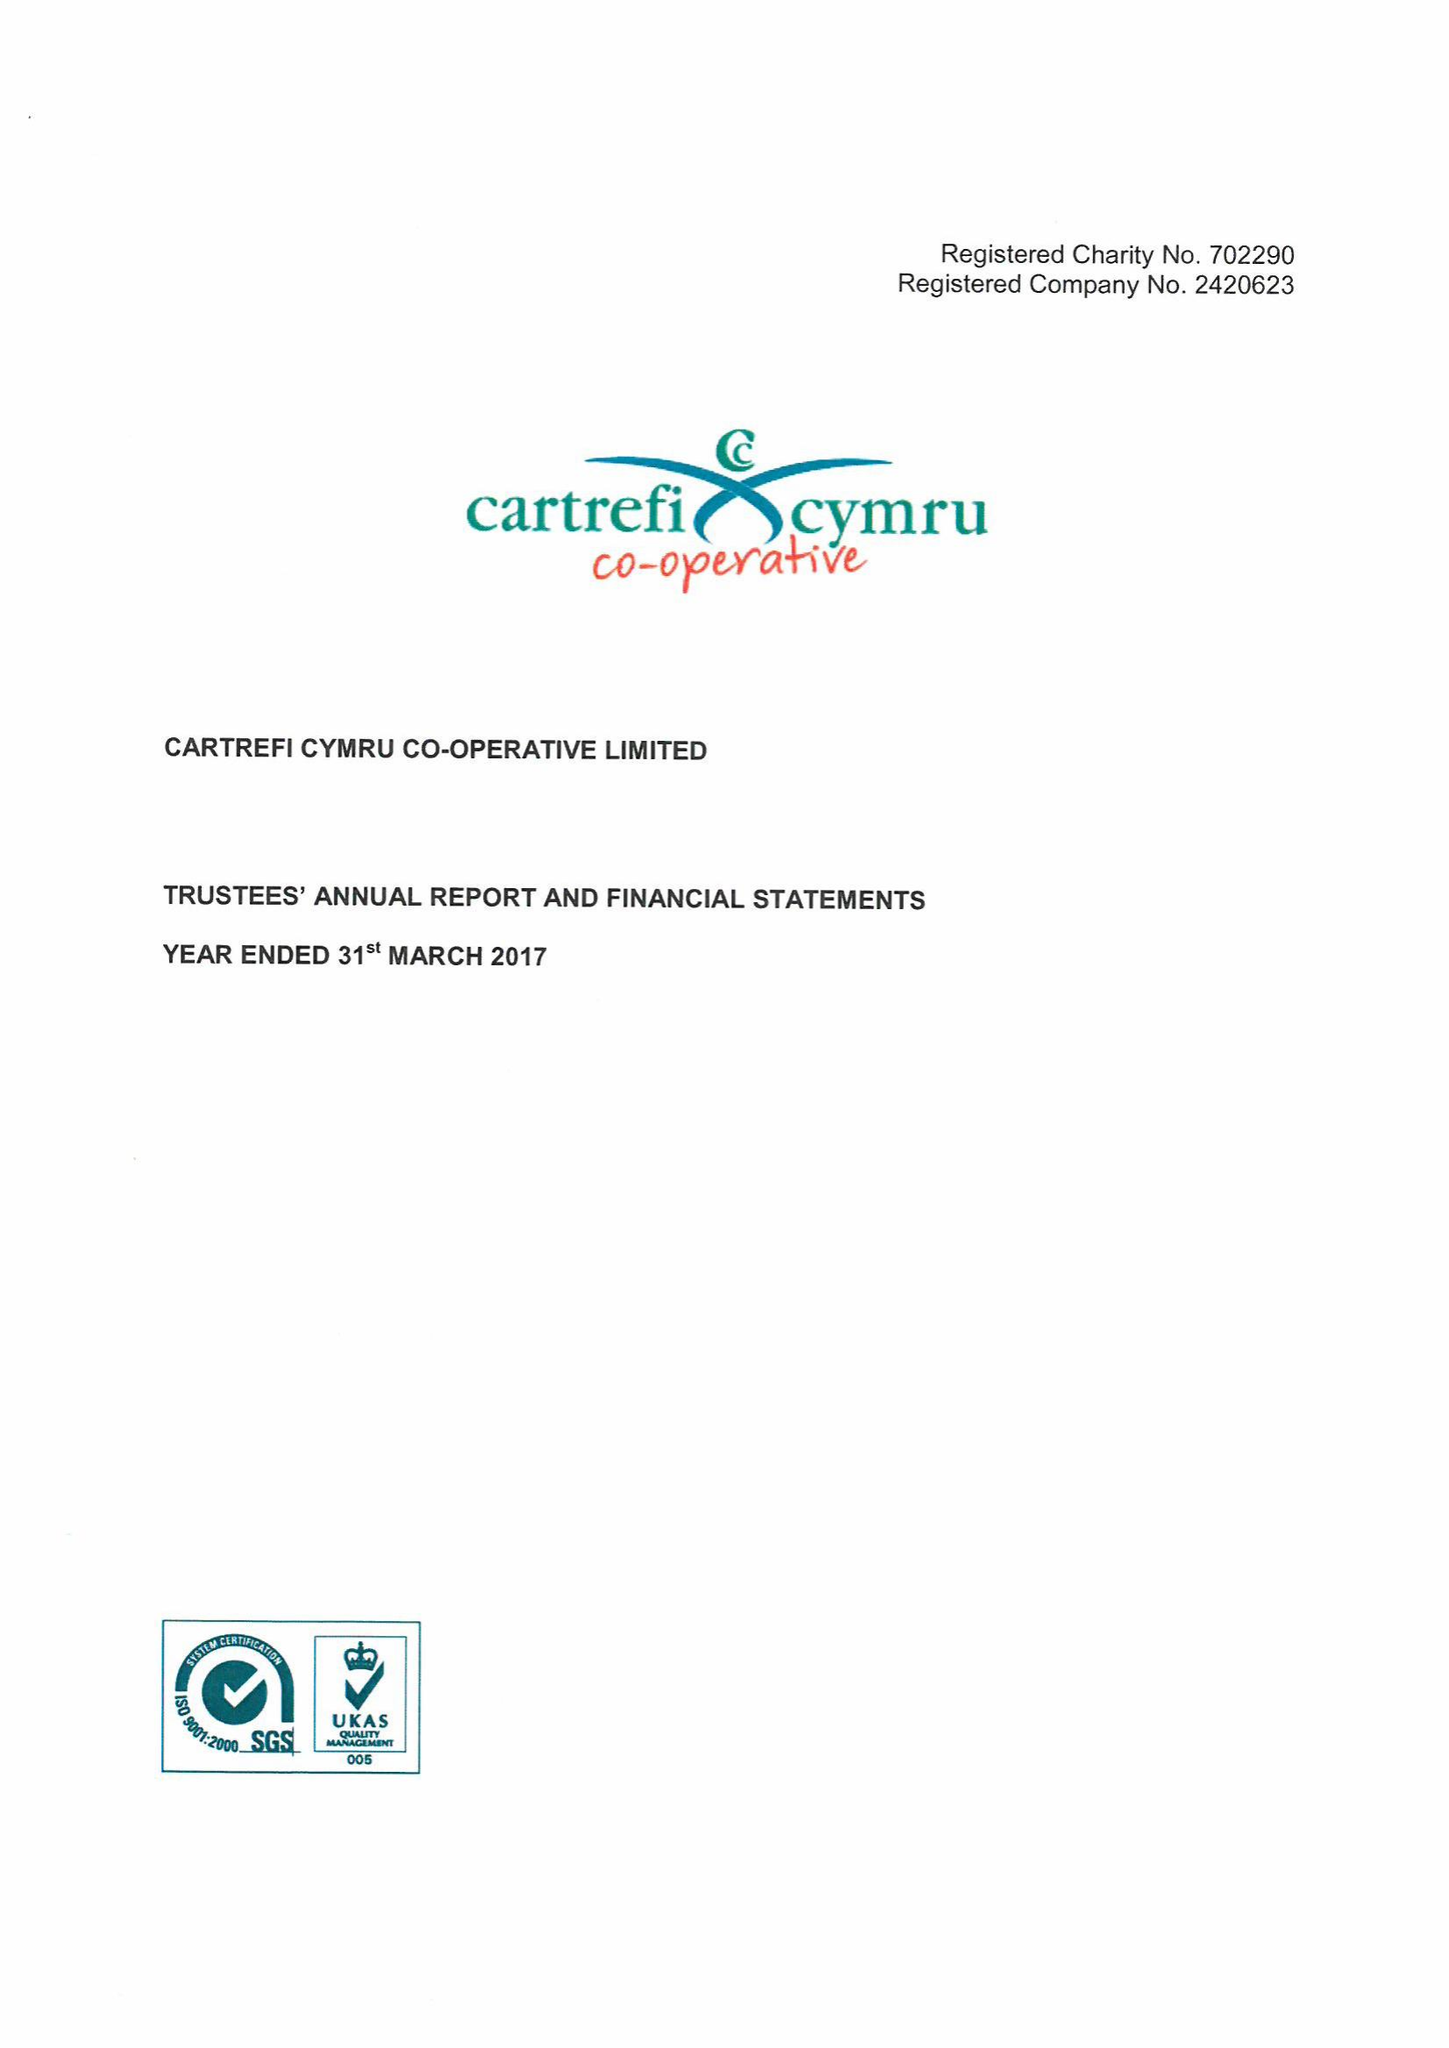What is the value for the report_date?
Answer the question using a single word or phrase. 2017-03-31 